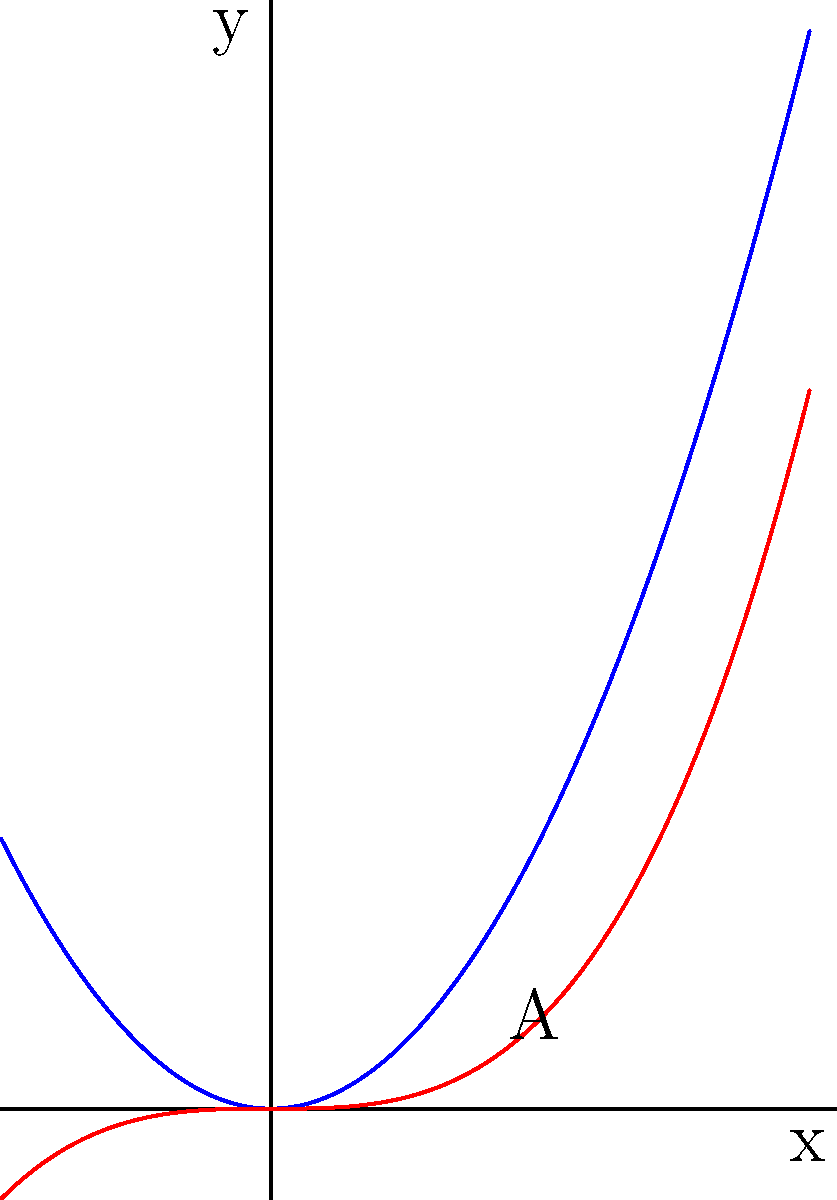In the context of USB data transfer rates, consider two polynomial functions representing different transfer speeds: $f(x) = x^2$ and $g(x) = \frac{x^3}{3}$. Calculate the area between these curves from $x=0$ to $x=1$, which could represent the difference in data transferred over a specific time interval. Express your answer in terms of square units of data transfer. To find the area between two curves, we need to:

1) Determine which function is on top in the given interval:
   For $0 \leq x \leq 1$, $f(x) = x^2 \geq \frac{x^3}{3} = g(x)$

2) Set up the integral:
   Area = $\int_0^1 [f(x) - g(x)] dx = \int_0^1 [x^2 - \frac{x^3}{3}] dx$

3) Integrate:
   $\int_0^1 [x^2 - \frac{x^3}{3}] dx = [\frac{x^3}{3} - \frac{x^4}{12}]_0^1$

4) Evaluate the integral:
   $[\frac{x^3}{3} - \frac{x^4}{12}]_0^1 = (\frac{1}{3} - \frac{1}{12}) - (0 - 0) = \frac{1}{3} - \frac{1}{12} = \frac{4}{12} - \frac{1}{12} = \frac{3}{12} = \frac{1}{4}$

Therefore, the area between the curves from $x=0$ to $x=1$ is $\frac{1}{4}$ square units of data transfer.
Answer: $\frac{1}{4}$ square units 